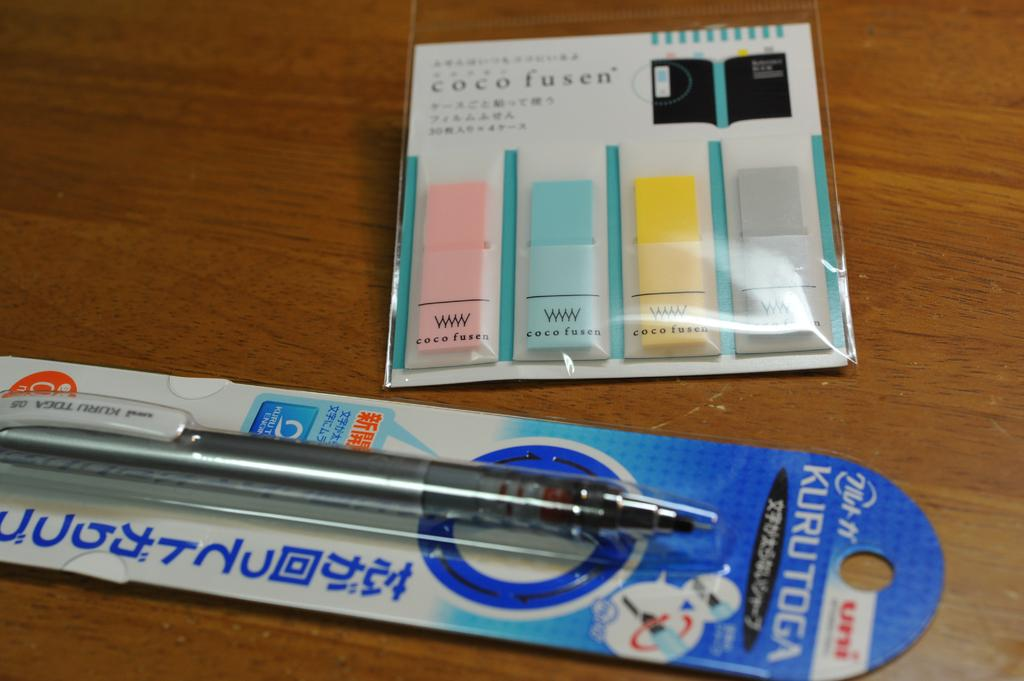What writing instrument is visible in the image? There is a pen in the image. What type of small, adhesive-backed paper can be seen in the image? There are sticky notes in the image. How many dolls are present in the image? There are no dolls present in the image. What type of clouds can be seen in the image? There are no clouds visible in the image. 